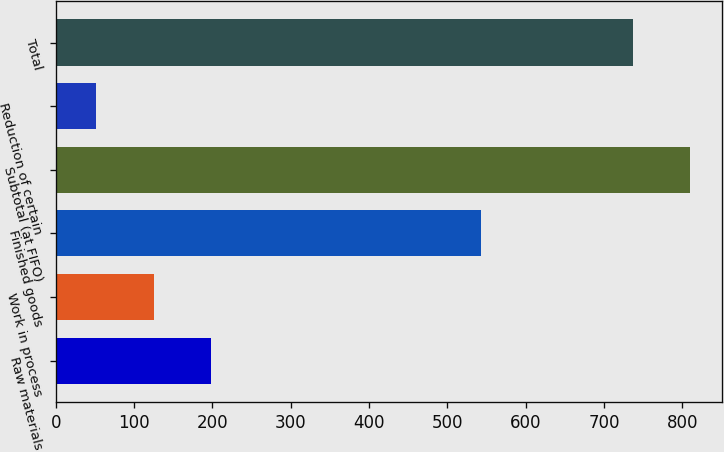<chart> <loc_0><loc_0><loc_500><loc_500><bar_chart><fcel>Raw materials<fcel>Work in process<fcel>Finished goods<fcel>Subtotal (at FIFO)<fcel>Reduction of certain<fcel>Total<nl><fcel>198.68<fcel>125.04<fcel>542.4<fcel>810.04<fcel>51.4<fcel>736.4<nl></chart> 